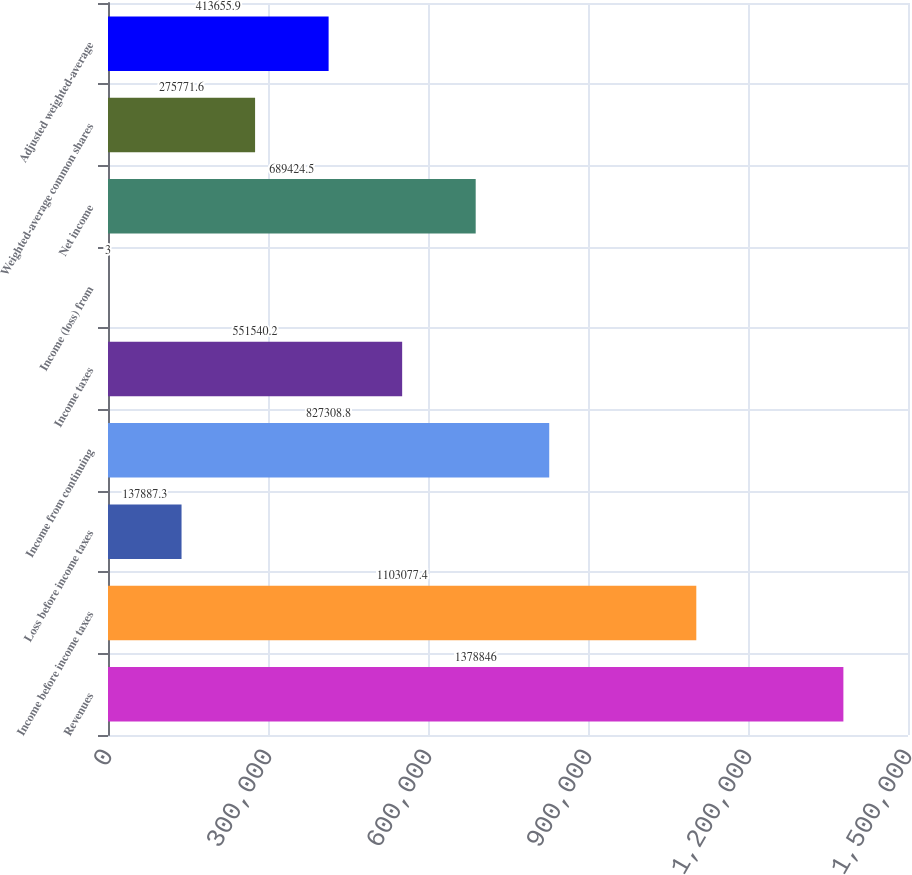Convert chart. <chart><loc_0><loc_0><loc_500><loc_500><bar_chart><fcel>Revenues<fcel>Income before income taxes<fcel>Loss before income taxes<fcel>Income from continuing<fcel>Income taxes<fcel>Income (loss) from<fcel>Net income<fcel>Weighted-average common shares<fcel>Adjusted weighted-average<nl><fcel>1.37885e+06<fcel>1.10308e+06<fcel>137887<fcel>827309<fcel>551540<fcel>3<fcel>689424<fcel>275772<fcel>413656<nl></chart> 